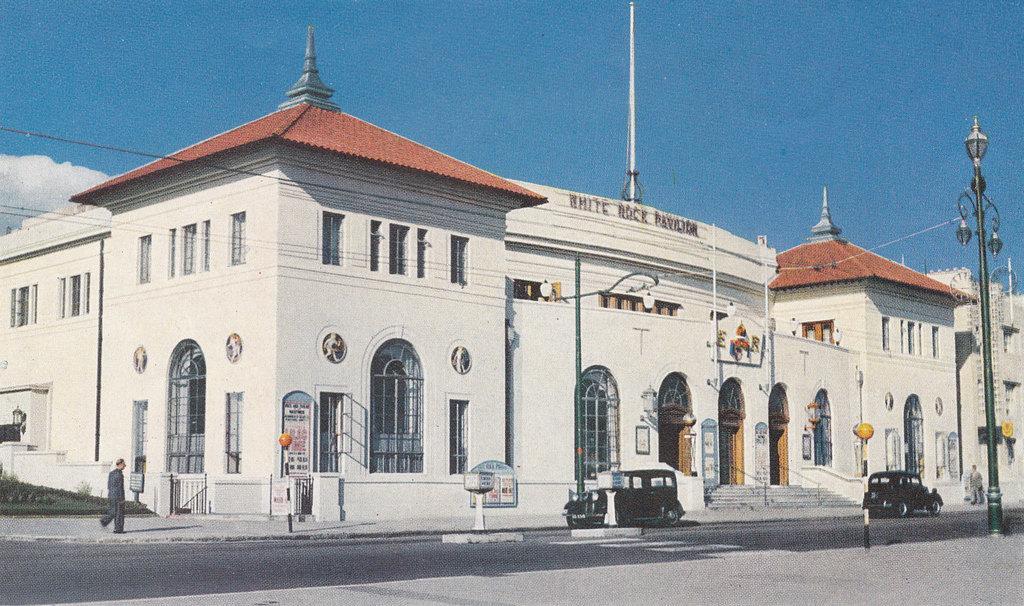How would you summarize this image in a sentence or two? In this image I can see on the left side a man is walking. Two vehicle are moving on the road, in the middle there is a big building, at the top it is the sky. 